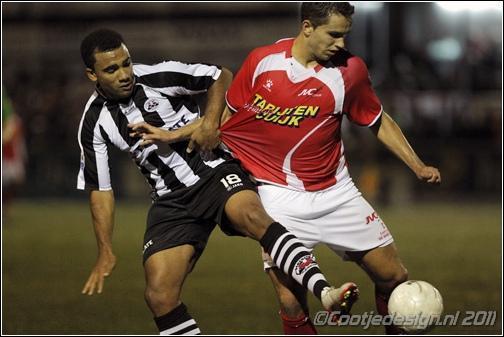How many people can you see?
Give a very brief answer. 2. 